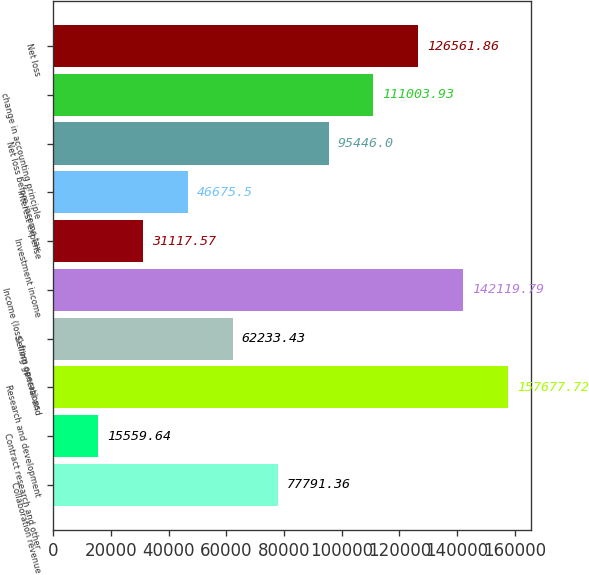Convert chart to OTSL. <chart><loc_0><loc_0><loc_500><loc_500><bar_chart><fcel>Collaboration revenue<fcel>Contract research and other<fcel>Research and development<fcel>Selling general and<fcel>Income (loss) from operations<fcel>Investment income<fcel>Interest expense<fcel>Net loss before income tax<fcel>change in accounting principle<fcel>Net loss<nl><fcel>77791.4<fcel>15559.6<fcel>157678<fcel>62233.4<fcel>142120<fcel>31117.6<fcel>46675.5<fcel>95446<fcel>111004<fcel>126562<nl></chart> 